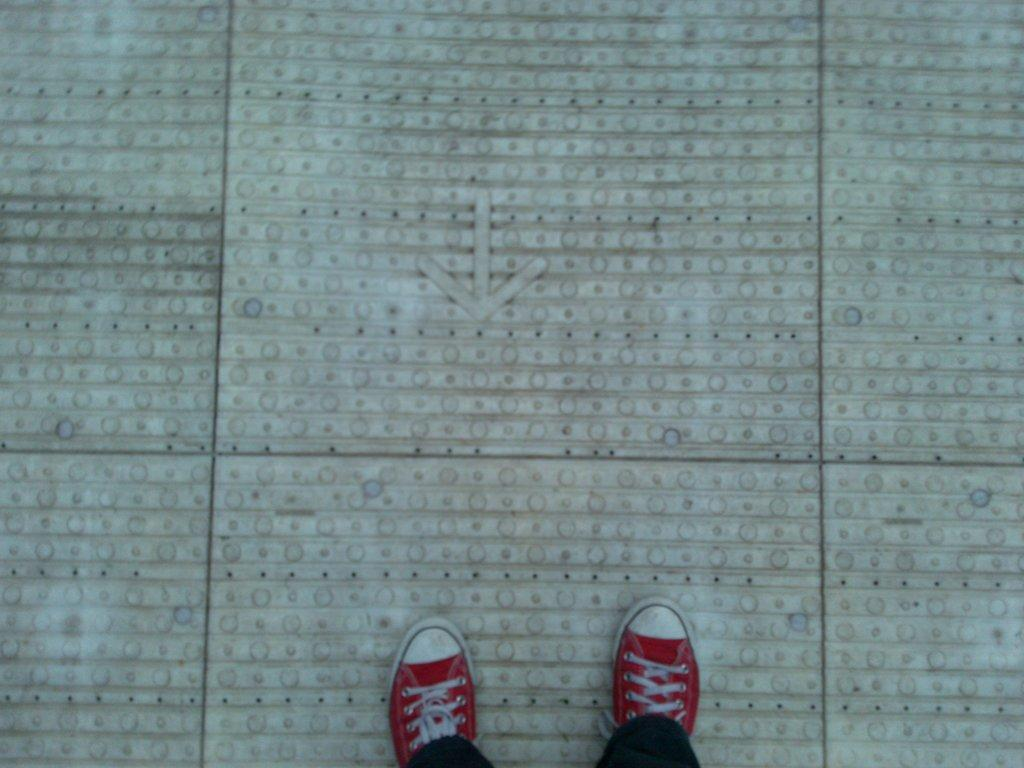What is present in the image? There is a person in the image. What is the person wearing on their feet? The person is wearing shoes. Where is the person located in the image? The person is standing on the floor. What time of day is the stranger surprising the person in the image? There is no stranger present in the image, and the time of day cannot be determined from the provided facts. 